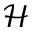<formula> <loc_0><loc_0><loc_500><loc_500>\mathcal { H }</formula> 